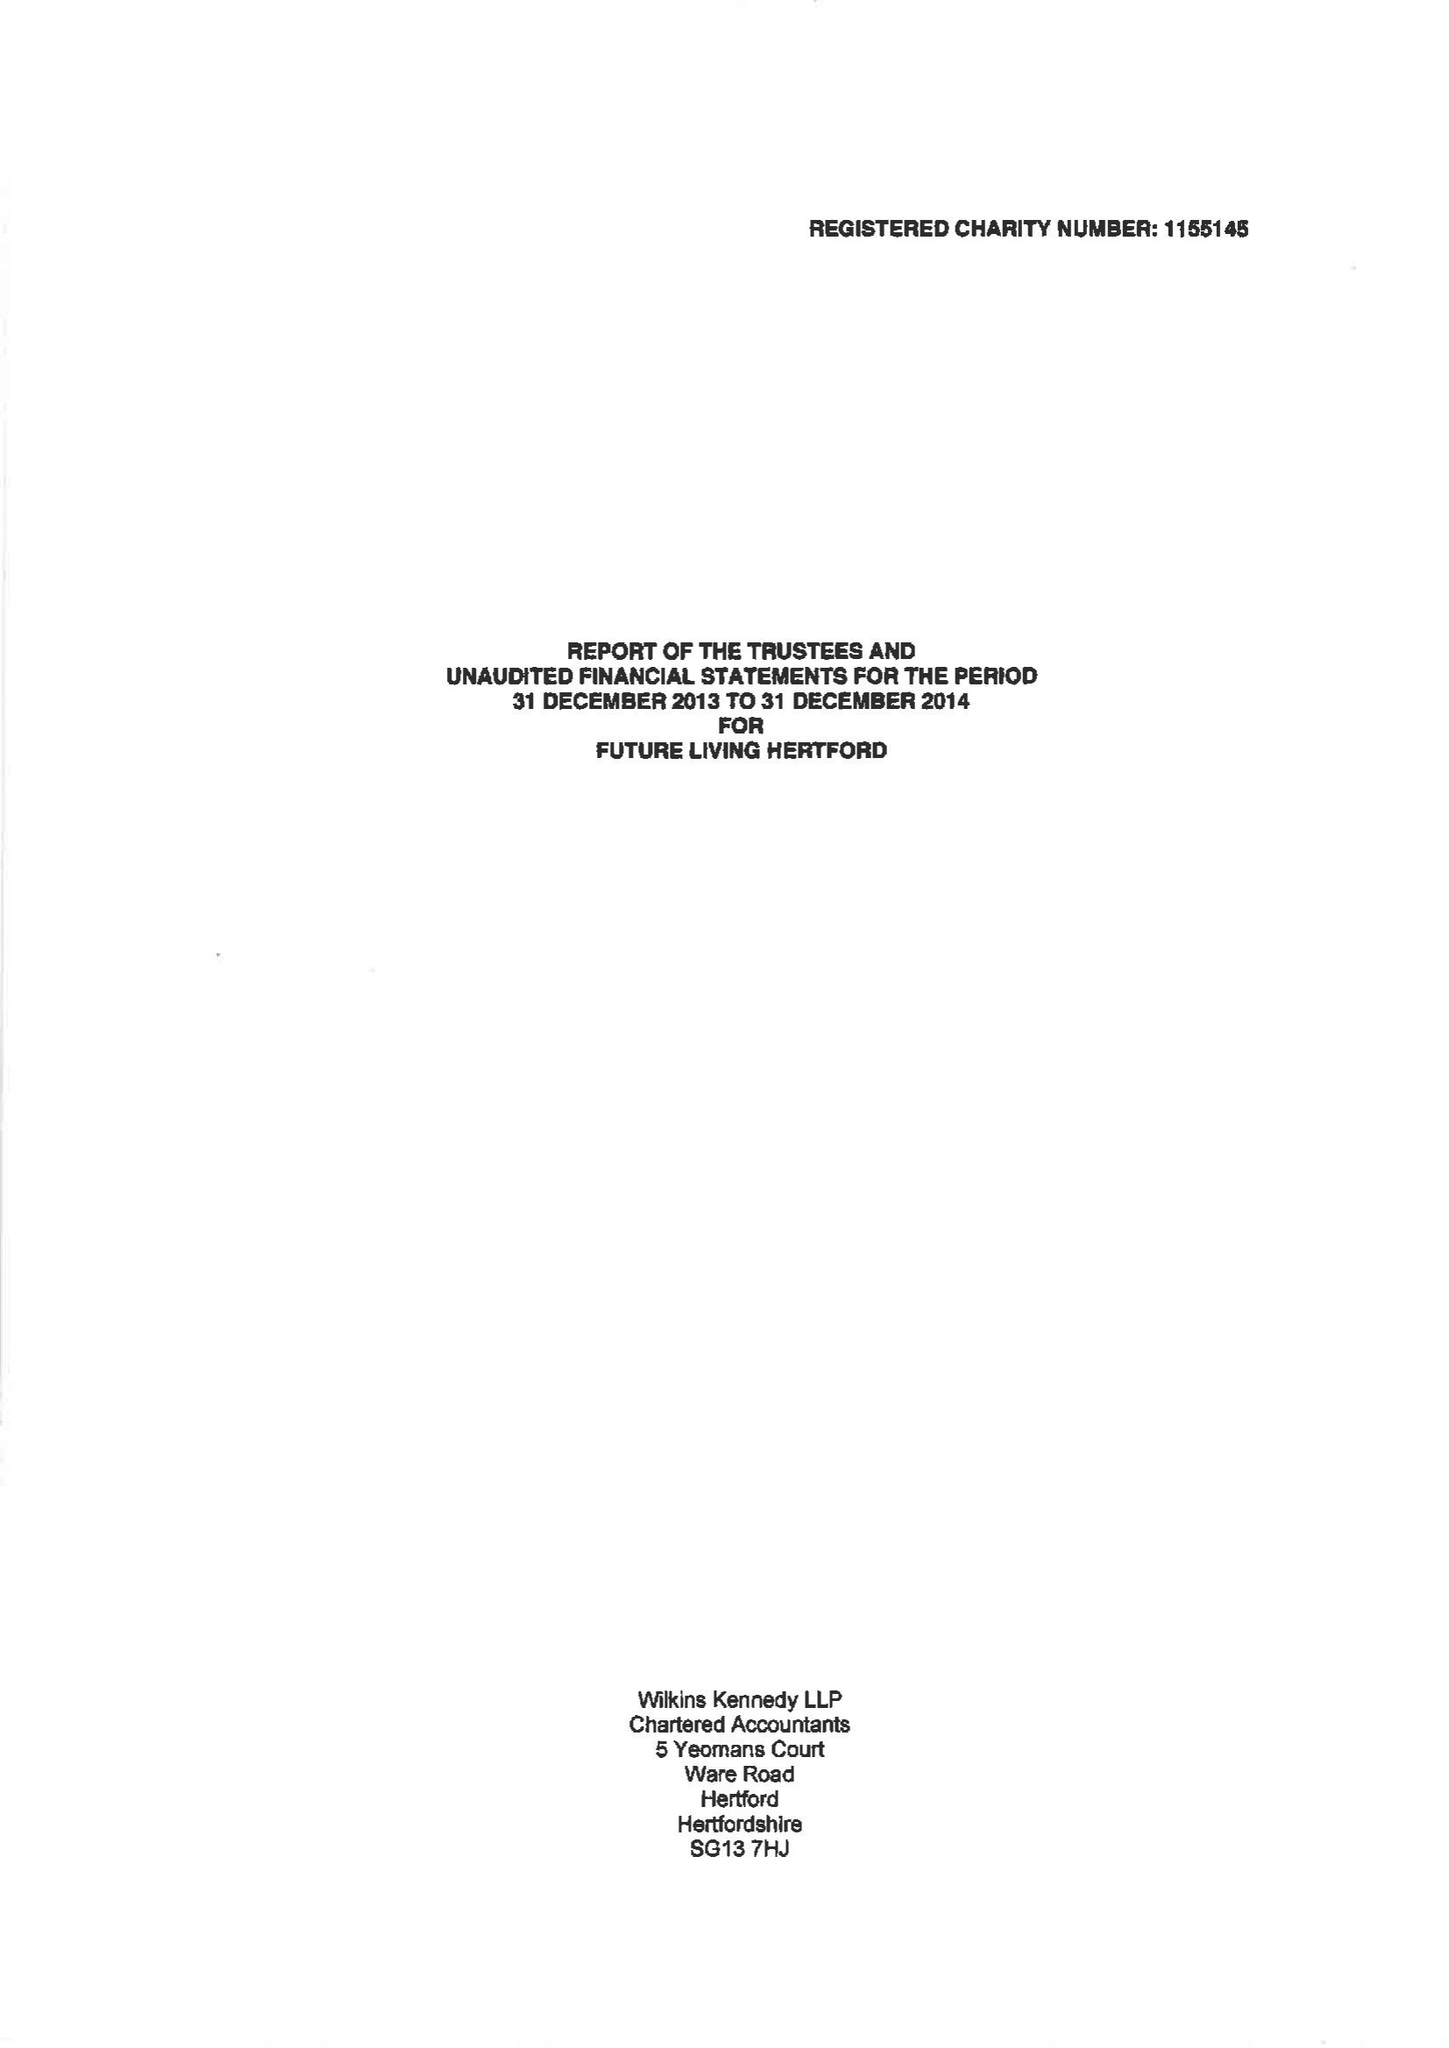What is the value for the report_date?
Answer the question using a single word or phrase. 2014-12-31 